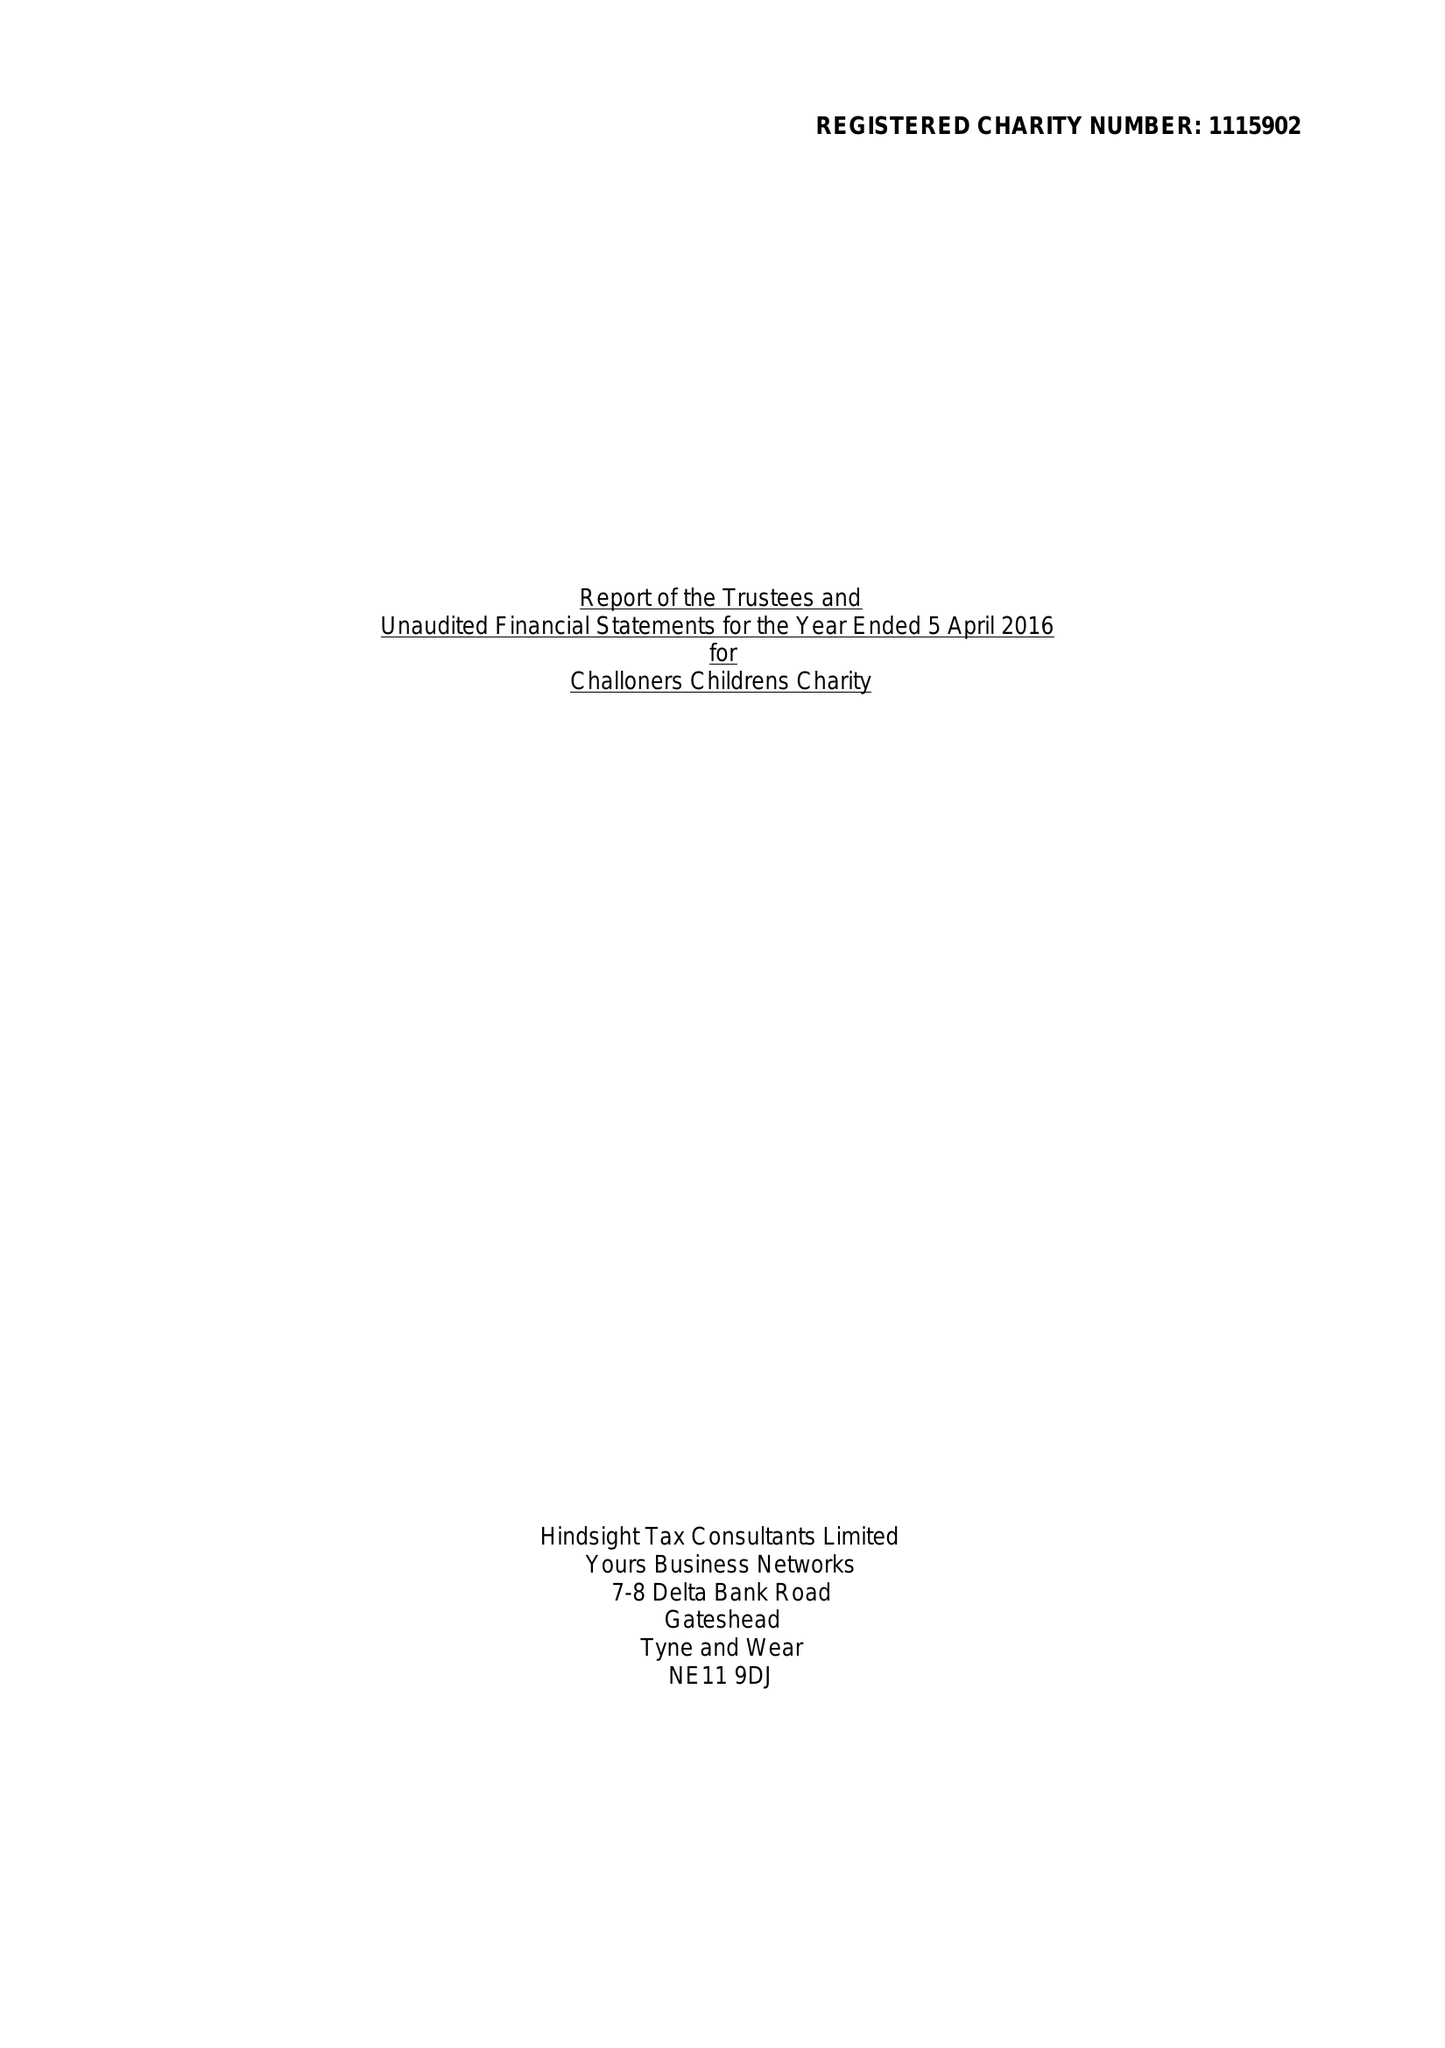What is the value for the spending_annually_in_british_pounds?
Answer the question using a single word or phrase. 22604.00 